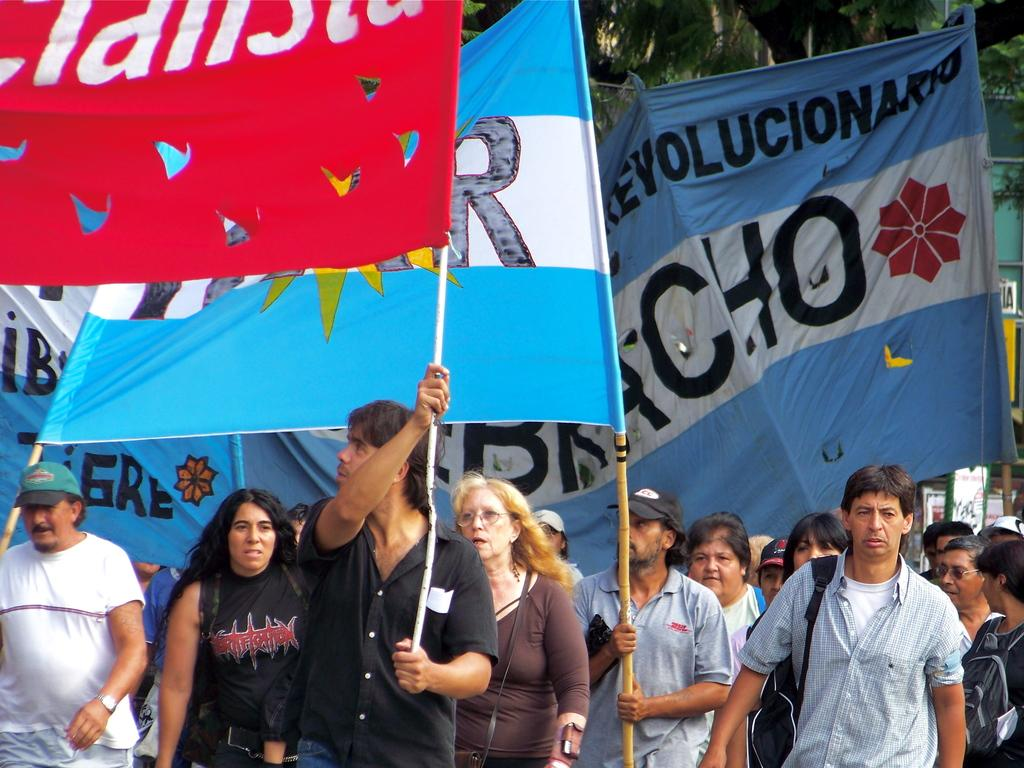<image>
Write a terse but informative summary of the picture. Some people march carrying flags and banners, the letters revolucion are visible on one. 